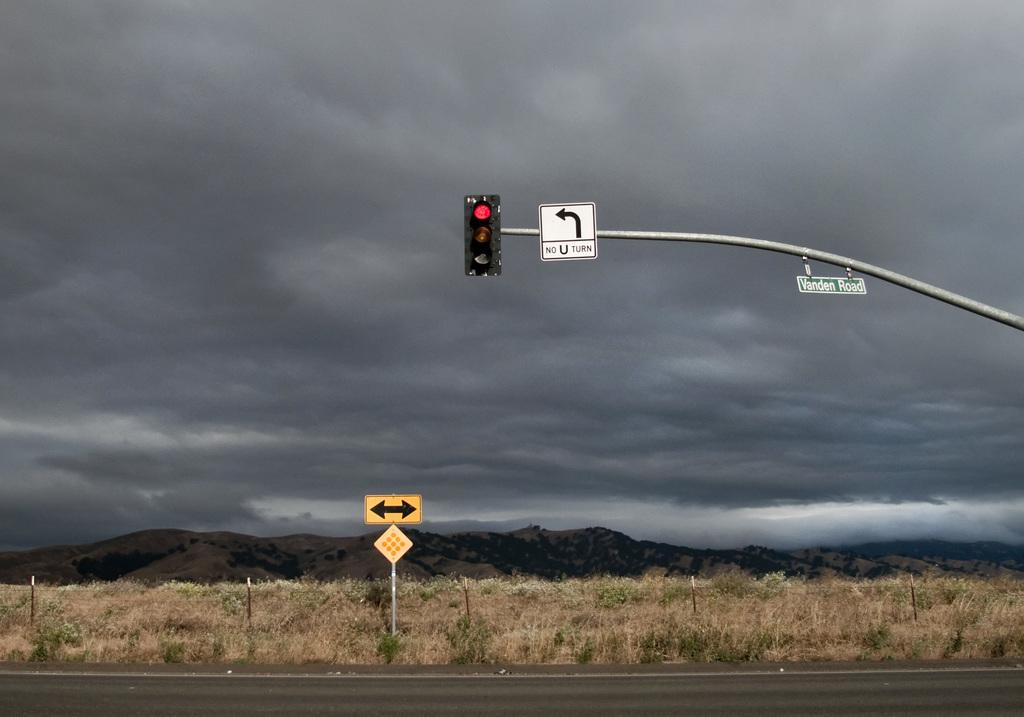<image>
Write a terse but informative summary of the picture. A white sign next to a traffic light on a pole says NO U TURN. 